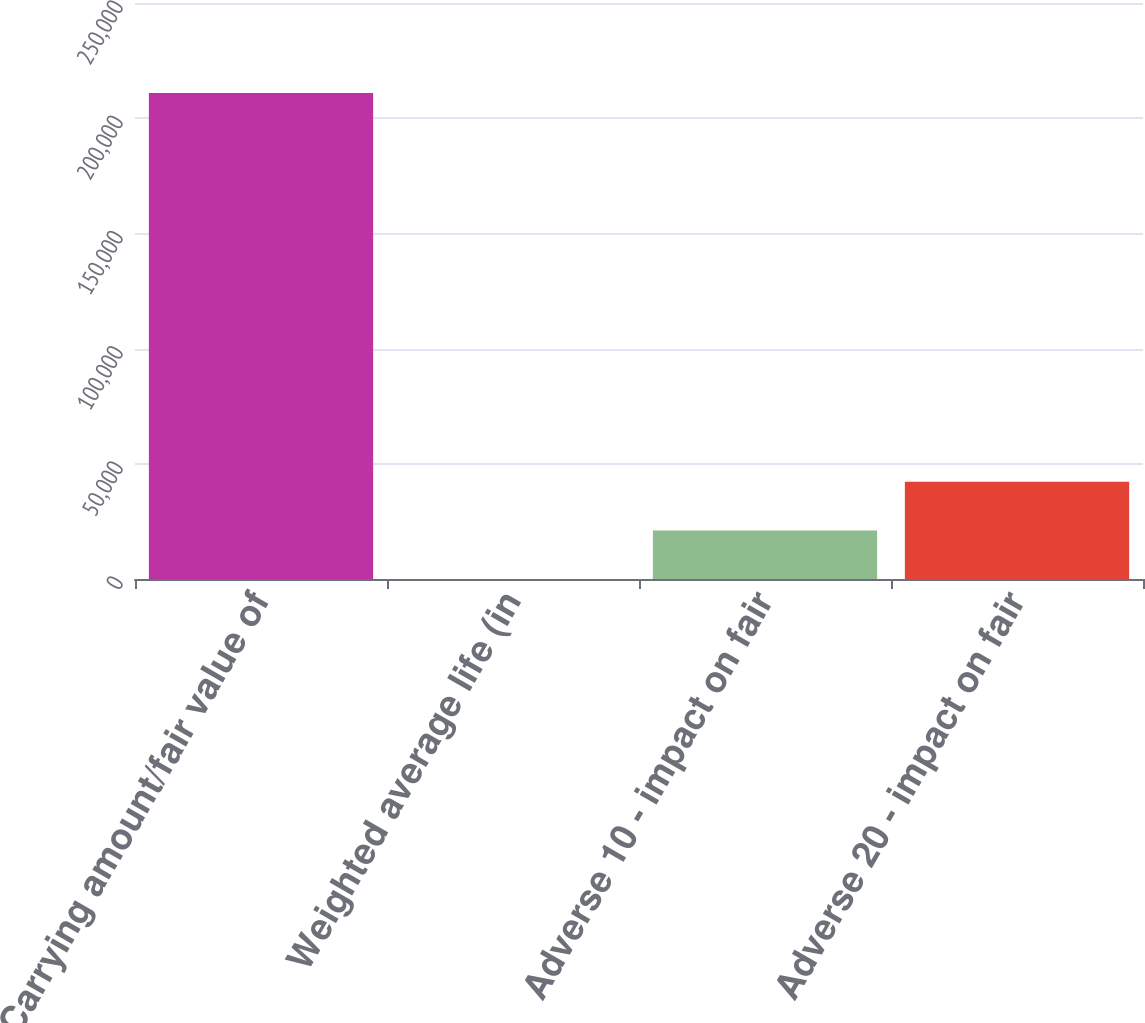Convert chart to OTSL. <chart><loc_0><loc_0><loc_500><loc_500><bar_chart><fcel>Carrying amount/fair value of<fcel>Weighted average life (in<fcel>Adverse 10 - impact on fair<fcel>Adverse 20 - impact on fair<nl><fcel>210973<fcel>1.4<fcel>21098.6<fcel>42195.7<nl></chart> 